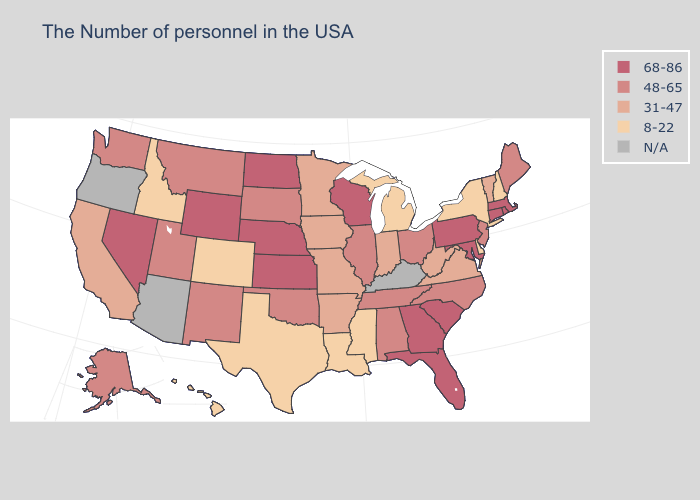What is the value of Alaska?
Short answer required. 48-65. What is the highest value in the USA?
Short answer required. 68-86. Does the first symbol in the legend represent the smallest category?
Keep it brief. No. Does the first symbol in the legend represent the smallest category?
Be succinct. No. Does Utah have the highest value in the USA?
Answer briefly. No. What is the value of Virginia?
Concise answer only. 31-47. What is the value of Maine?
Write a very short answer. 48-65. Does the map have missing data?
Be succinct. Yes. Does Mississippi have the lowest value in the USA?
Write a very short answer. Yes. Name the states that have a value in the range 68-86?
Give a very brief answer. Massachusetts, Rhode Island, Connecticut, Maryland, Pennsylvania, South Carolina, Florida, Georgia, Wisconsin, Kansas, Nebraska, North Dakota, Wyoming, Nevada. What is the highest value in the West ?
Short answer required. 68-86. Is the legend a continuous bar?
Be succinct. No. Name the states that have a value in the range N/A?
Answer briefly. Kentucky, Arizona, Oregon. What is the value of West Virginia?
Write a very short answer. 31-47. Which states have the lowest value in the Northeast?
Answer briefly. New Hampshire, New York. 